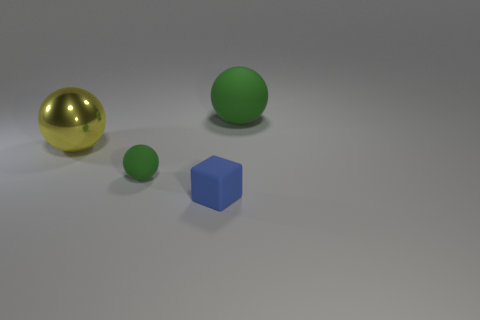What materials are the objects in the picture made of? The objects in the image appear to be made of different materials. The large sphere seems to be made of a shiny metal, likely representing something similar to gold. The two smaller spheres and the cube, which is blue, seem to be made of a matte material, possibly rubber or plastic. 